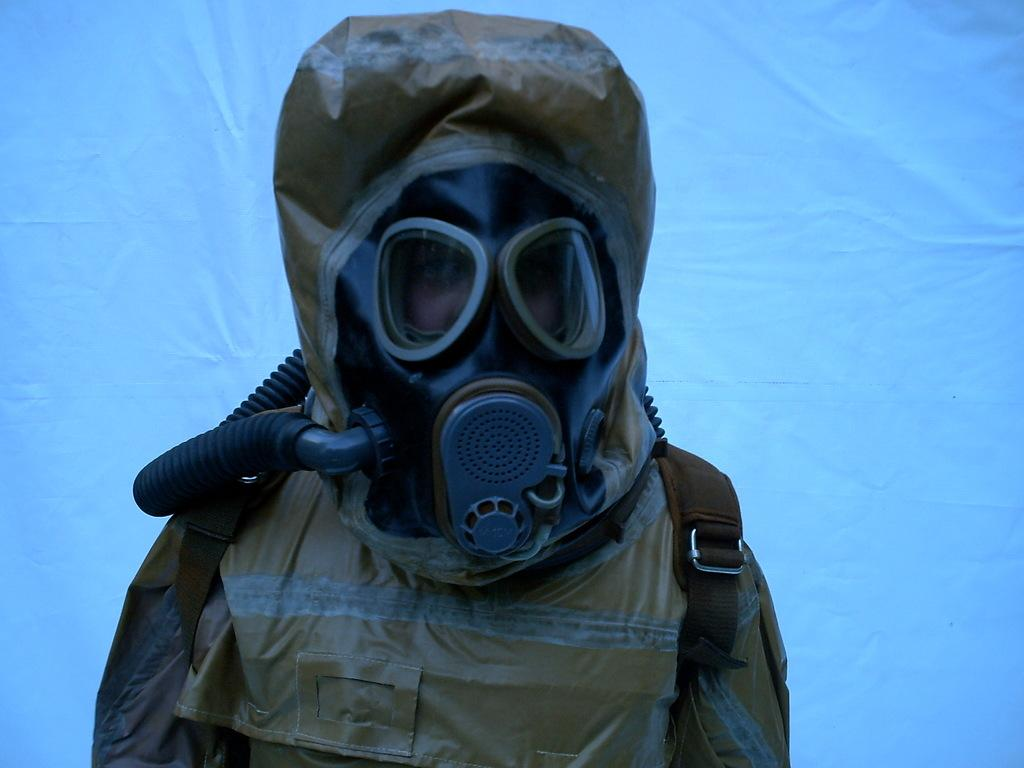What is the main subject of the image? There is a person in the image. What type of clothing is the person wearing? The person is wearing a chemical suit. What color is the background of the image? The background of the image is blue. What type of vest can be seen on the person in the image? There is no vest visible on the person in the image; they are wearing a chemical suit. What type of clouds are present in the image? There are no clouds present in the image, as it only features a person wearing a chemical suit with a blue background. 